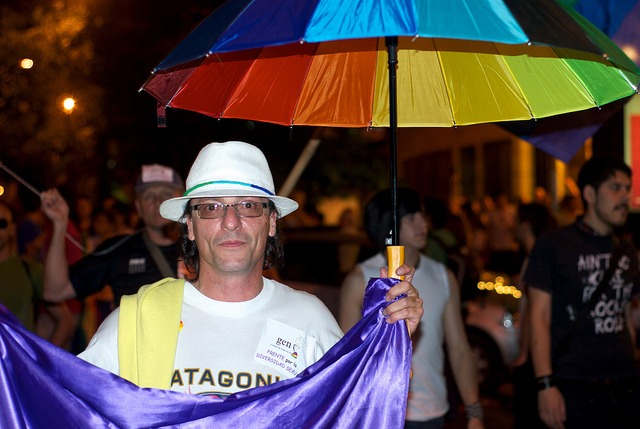How many people are in the picture? There's one person in the center of the picture, prominently holding a colorful umbrella and draped in a purple cloth. 